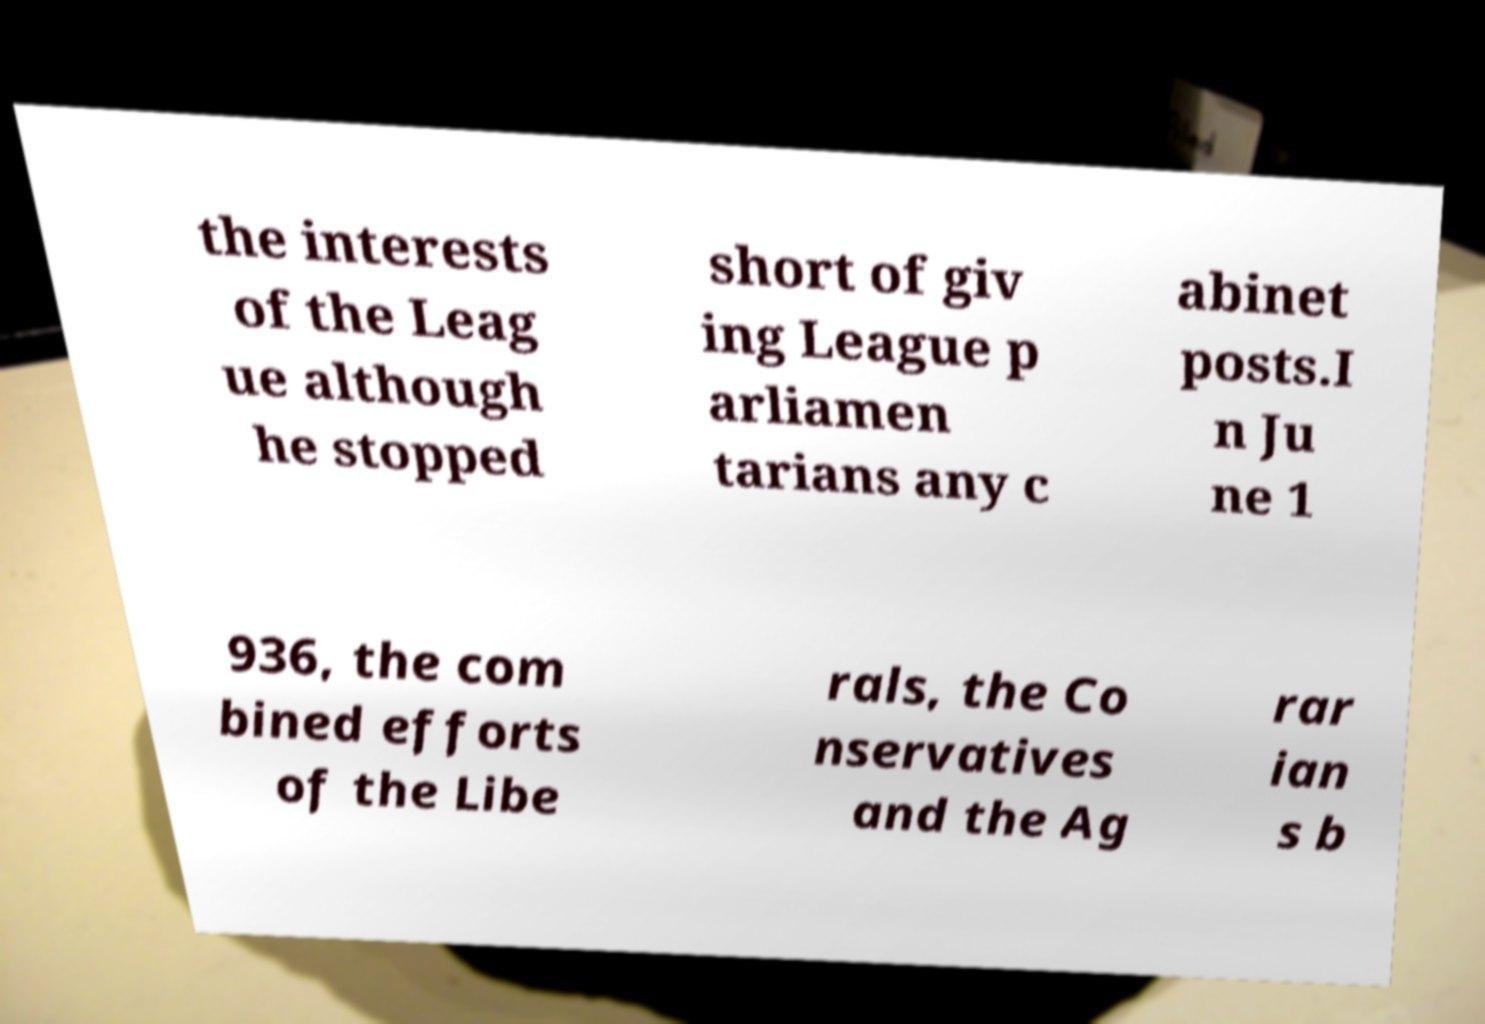Please read and relay the text visible in this image. What does it say? the interests of the Leag ue although he stopped short of giv ing League p arliamen tarians any c abinet posts.I n Ju ne 1 936, the com bined efforts of the Libe rals, the Co nservatives and the Ag rar ian s b 